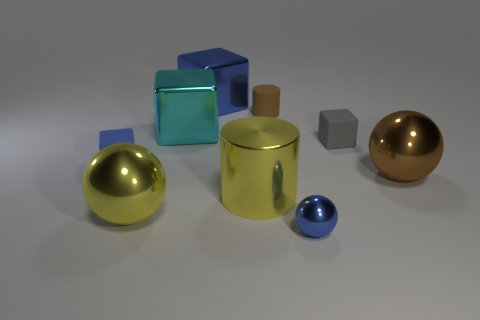Subtract all brown balls. How many blue blocks are left? 2 Subtract all big spheres. How many spheres are left? 1 Subtract all cyan cubes. How many cubes are left? 3 Subtract 1 cubes. How many cubes are left? 3 Subtract all yellow blocks. Subtract all blue cylinders. How many blocks are left? 4 Subtract all blocks. How many objects are left? 5 Subtract 0 gray balls. How many objects are left? 9 Subtract all big red metallic objects. Subtract all brown rubber cylinders. How many objects are left? 8 Add 5 blue balls. How many blue balls are left? 6 Add 7 shiny cubes. How many shiny cubes exist? 9 